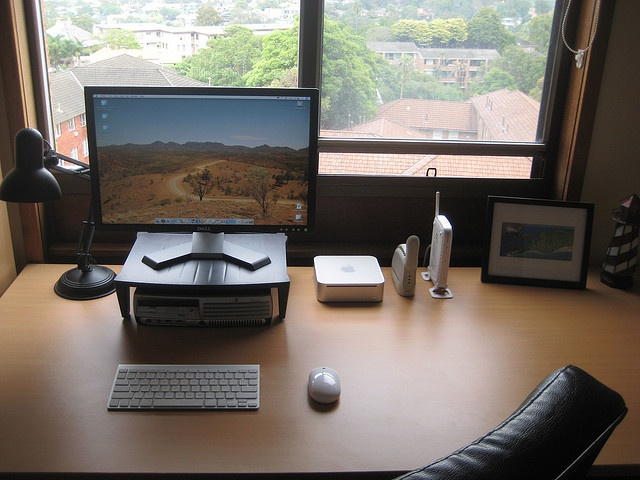Describe the objects in this image and their specific colors. I can see tv in black, gray, and maroon tones, chair in black, gray, and darkgray tones, keyboard in black and gray tones, and mouse in black, darkgray, gray, and lightgray tones in this image. 